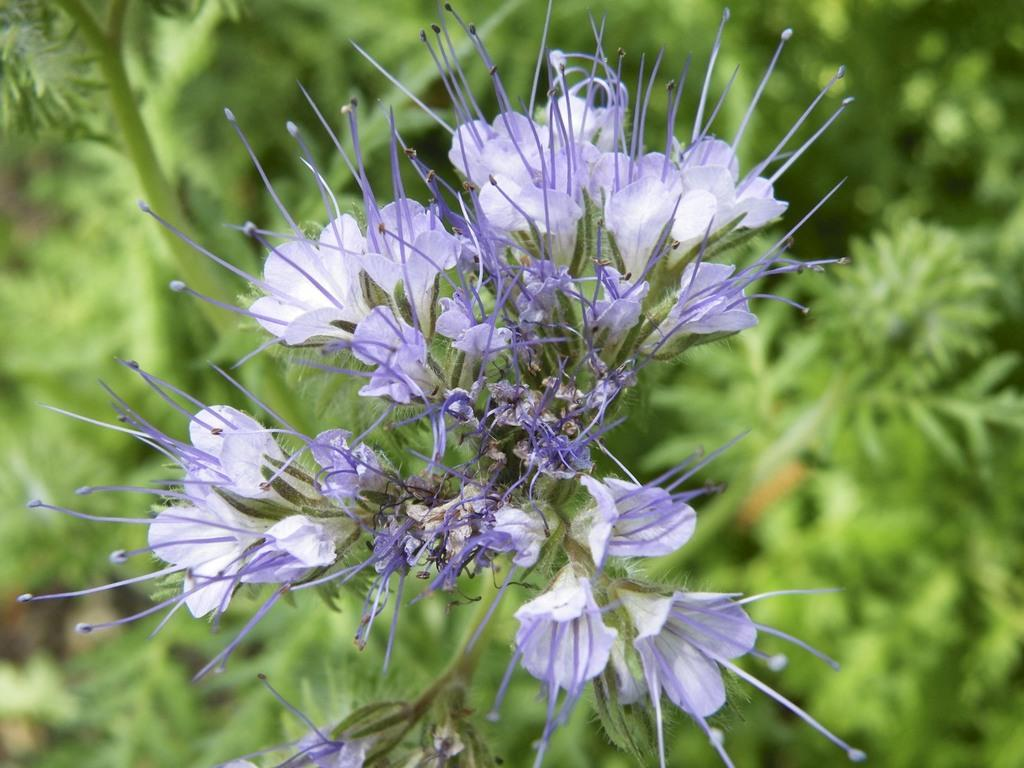What type of flowers can be seen on a plant in the image? There are purple flowers on a plant in the image. Can you describe the plants in the background of the image? Unfortunately, the provided facts do not give any information about the plants in the background. However, we can confirm that there are plants visible in the background. What type of list can be seen hanging on the wall in the image? There is no list present in the image; it features purple flowers on a plant and plants in the background. How many chickens are visible in the image? There are no chickens present in the image. 